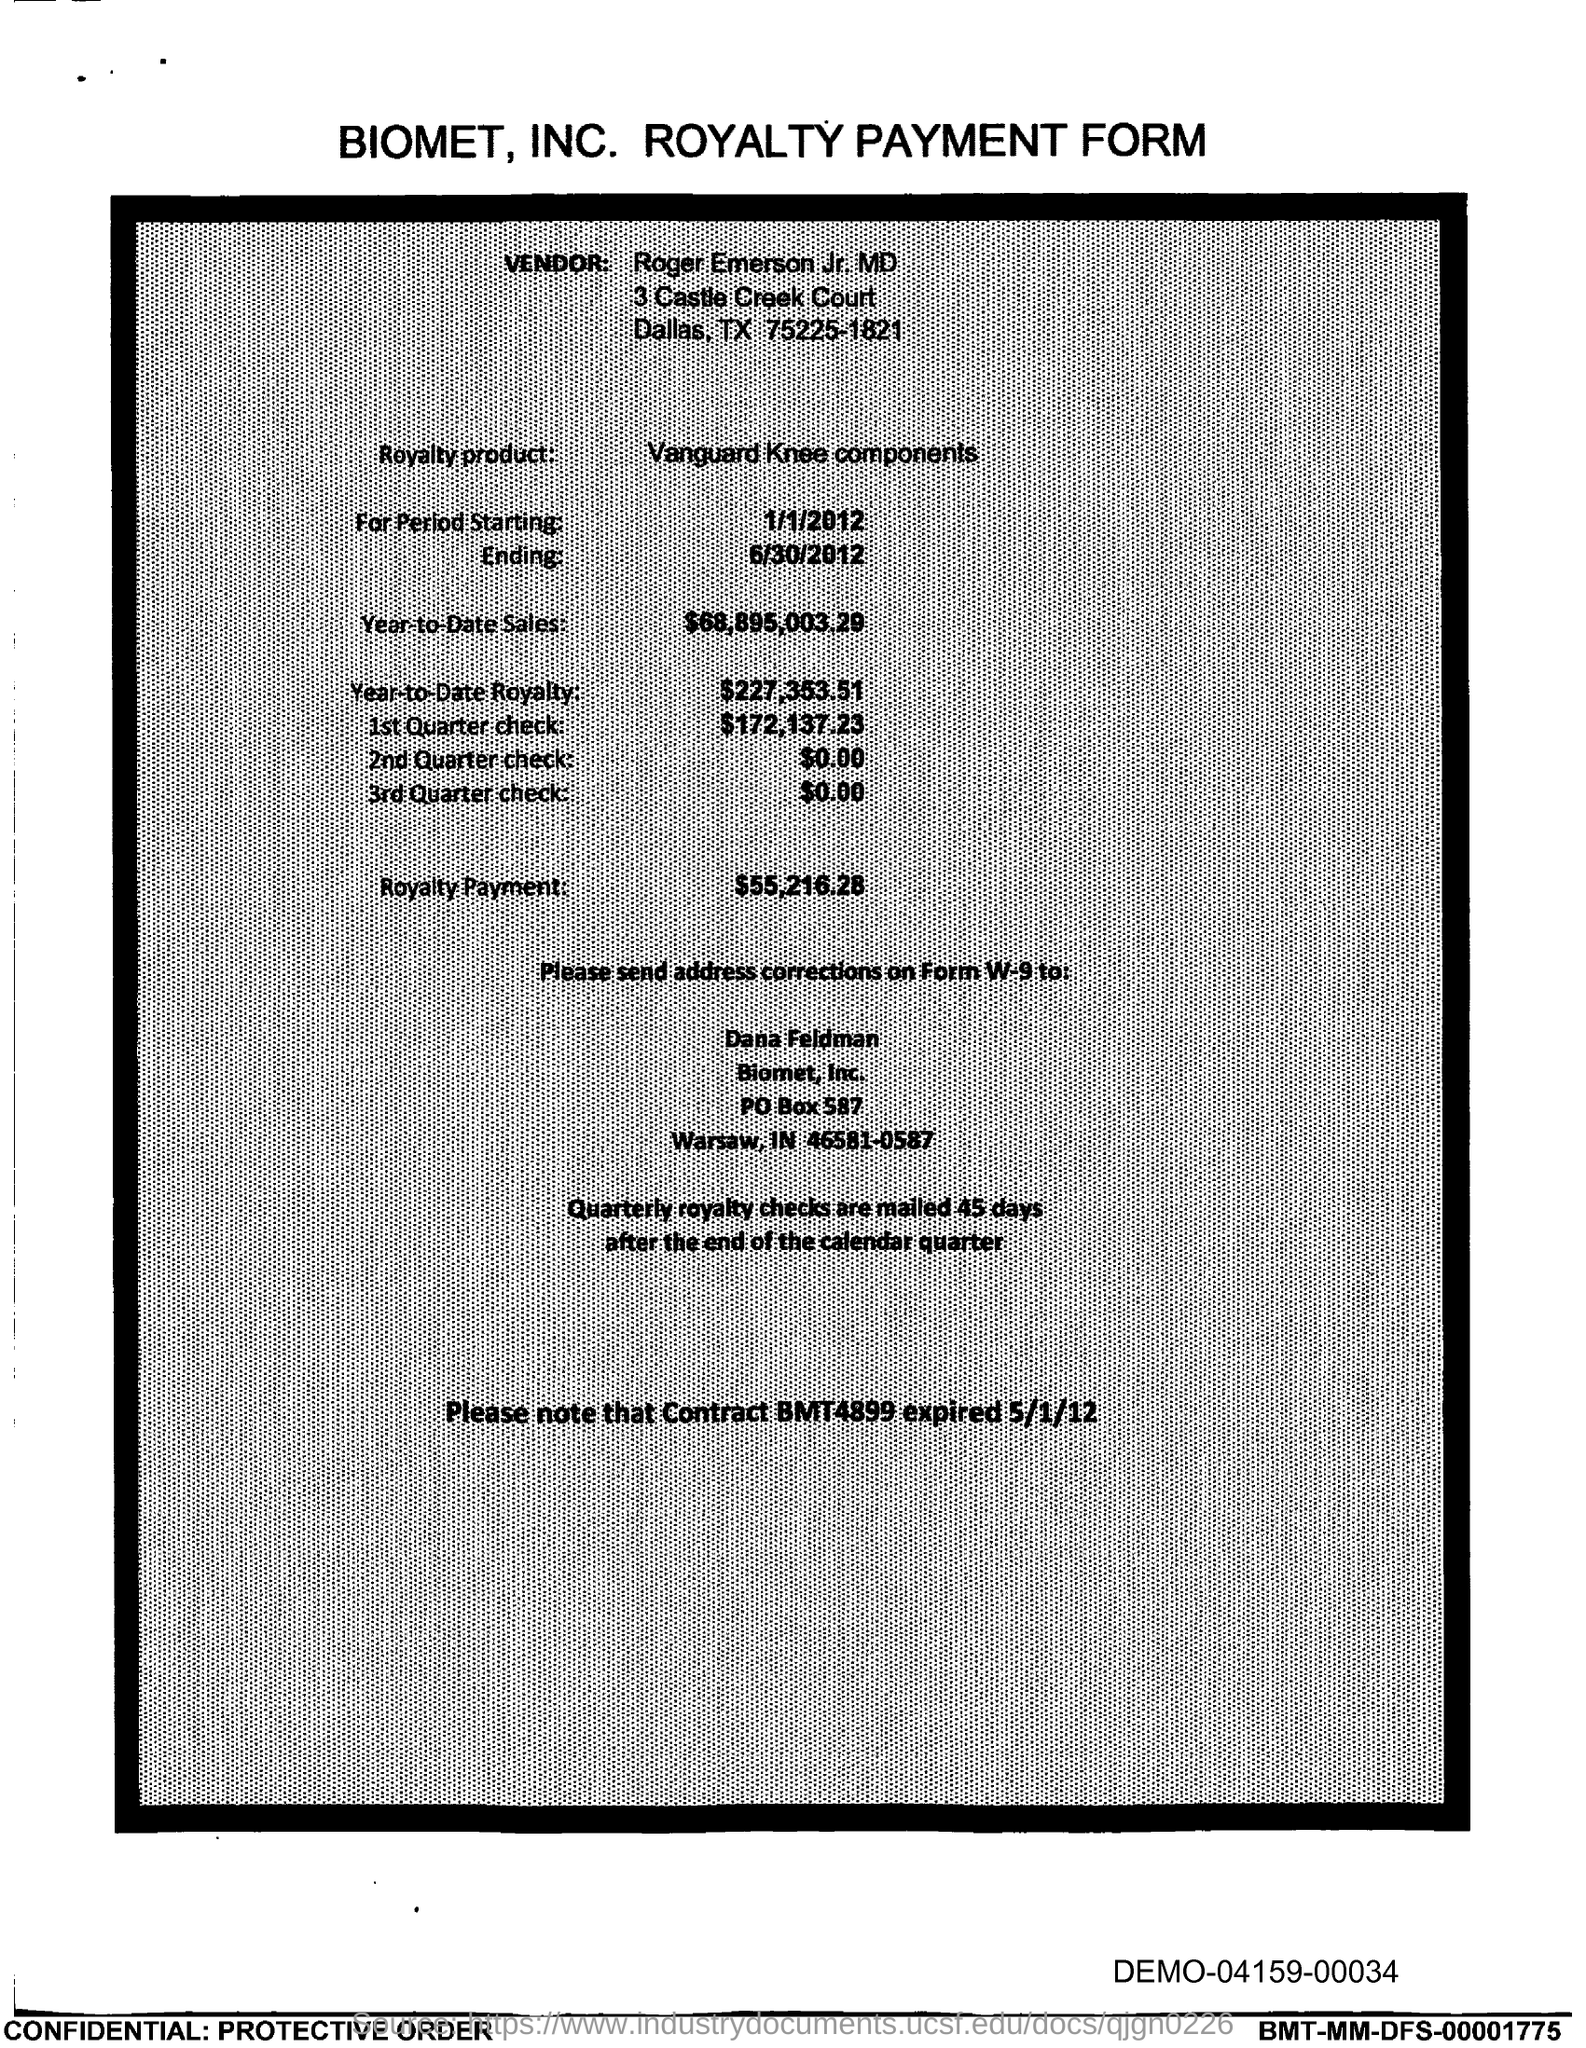What kind of form is this document?
Offer a very short reply. Biomet, Inc. Royalty Payment Form. What is the vendor name given in this document?
Provide a succinct answer. Roger Emerson. What is the name of the Royalty product?
Your answer should be compact. Vanguard Knee components. What is the period starting date given?
Your answer should be very brief. 1/1/2012. What is the ending date given in this document?
Your answer should be very brief. 6/30/2012. What is the value for Year-to-Date Sales?
Make the answer very short. $68,895,003.29. What is the value for Year-to-Date Royalty?
Keep it short and to the point. 227,353.51. What is the value for 1st Quarter check?
Your answer should be compact. $172,137.23. What is the value for Royalty Payment?
Your response must be concise. $55,216.28. What is Contract BMT4899 expired date?
Make the answer very short. 5/1/12. 